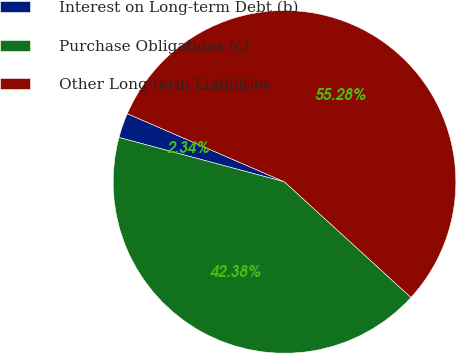Convert chart. <chart><loc_0><loc_0><loc_500><loc_500><pie_chart><fcel>Interest on Long-term Debt (b)<fcel>Purchase Obligations (c)<fcel>Other Long-term Liabilities<nl><fcel>2.34%<fcel>42.38%<fcel>55.27%<nl></chart> 